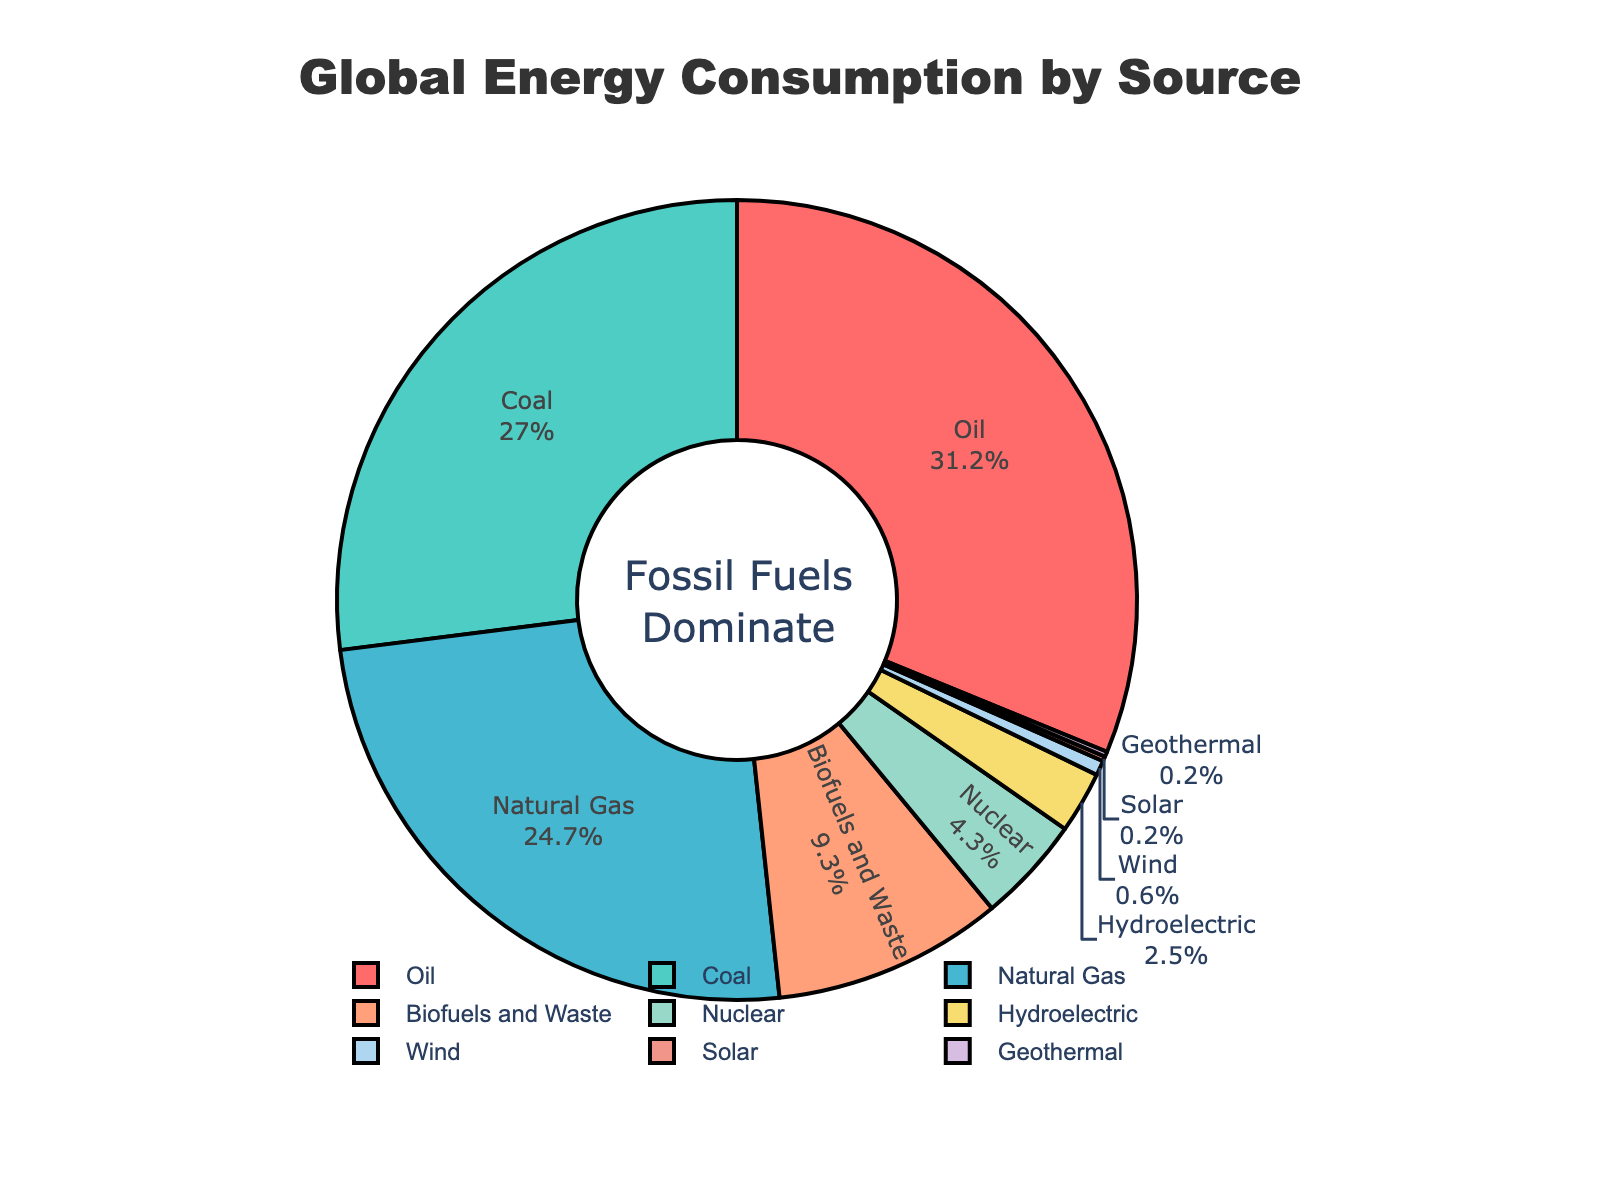What is the combined percentage of energy consumption from Oil and Natural Gas? Sum the percentage values of Oil (31.2%) and Natural Gas (24.7%). 31.2 + 24.7 = 55.9
Answer: 55.9 How much higher is the percentage of energy consumption from Oil compared to Biofuels and Waste? Subtract the percentage of Biofuels and Waste (9.3%) from Oil (31.2%). 31.2 - 9.3 = 21.9
Answer: 21.9 Which energy source has a higher percentage, Coal or Nuclear? Compare the percentage values of Coal (27.0%) and Nuclear (4.3%). 27.0 > 4.3
Answer: Coal What is the combined percentage of renewable energy sources (Biofuels and Waste, Hydroelectric, Wind, Solar, Geothermal)? Sum the percentage values of renewable sources: 9.3 (Biofuels and Waste) + 2.5 (Hydroelectric) + 0.6 (Wind) + 0.2 (Solar) + 0.2 (Geothermal). 9.3 + 2.5 + 0.6 + 0.2 + 0.2 = 12.8
Answer: 12.8 Which portion of the pie chart is larger, Nuclear or Hydroelectric? Compare the percentage values of Nuclear (4.3%) and Hydroelectric (2.5%). 4.3 > 2.5
Answer: Nuclear What percentage of energy consumption is represented by fossil fuels (Oil, Coal, Natural Gas)? Sum the percentage values of fossil fuels: 31.2 (Oil) + 27.0 (Coal) + 24.7 (Natural Gas). 31.2 + 27.0 + 24.7 = 82.9
Answer: 82.9 List the energy sources in descending order of their percentage contribution to global energy consumption. Arrange the sources based on their given percentages from highest to lowest: Oil (31.2), Coal (27.0), Natural Gas (24.7), Biofuels and Waste (9.3), Nuclear (4.3), Hydroelectric (2.5), Wind (0.6), Solar (0.2), Geothermal (0.2)
Answer: Oil, Coal, Natural Gas, Biofuels and Waste, Nuclear, Hydroelectric, Wind, Solar, Geothermal What is the difference in percentage between Hydroelectric and Wind energy? Subtract the percentage of Wind (0.6%) from Hydroelectric (2.5%). 2.5 - 0.6 = 1.9
Answer: 1.9 